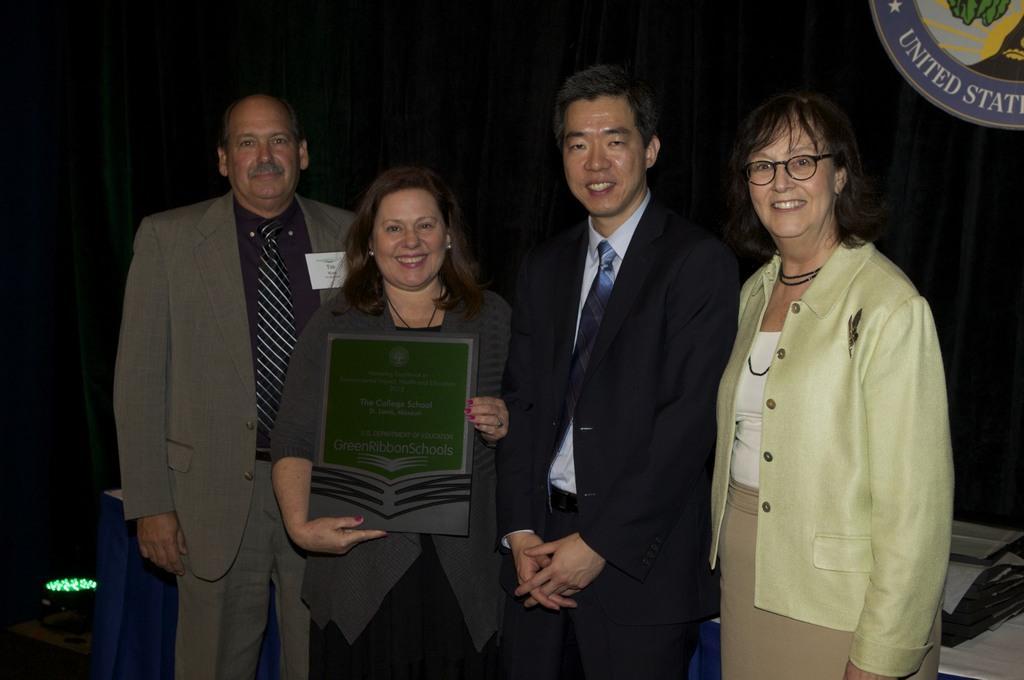Please provide a concise description of this image. In the image we can see two men and two women, standing, wearing clothes and they are smiling. Here we can see a woman holding an object in her hands. Here we can see the board and text on the board and the curtains. 